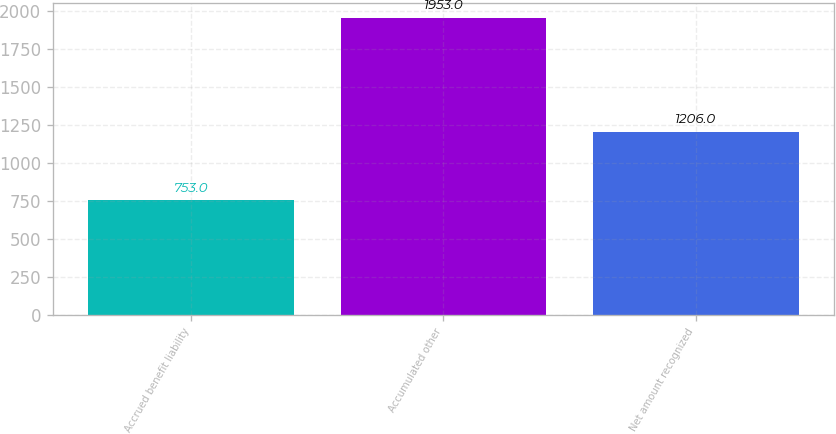Convert chart. <chart><loc_0><loc_0><loc_500><loc_500><bar_chart><fcel>Accrued benefit liability<fcel>Accumulated other<fcel>Net amount recognized<nl><fcel>753<fcel>1953<fcel>1206<nl></chart> 